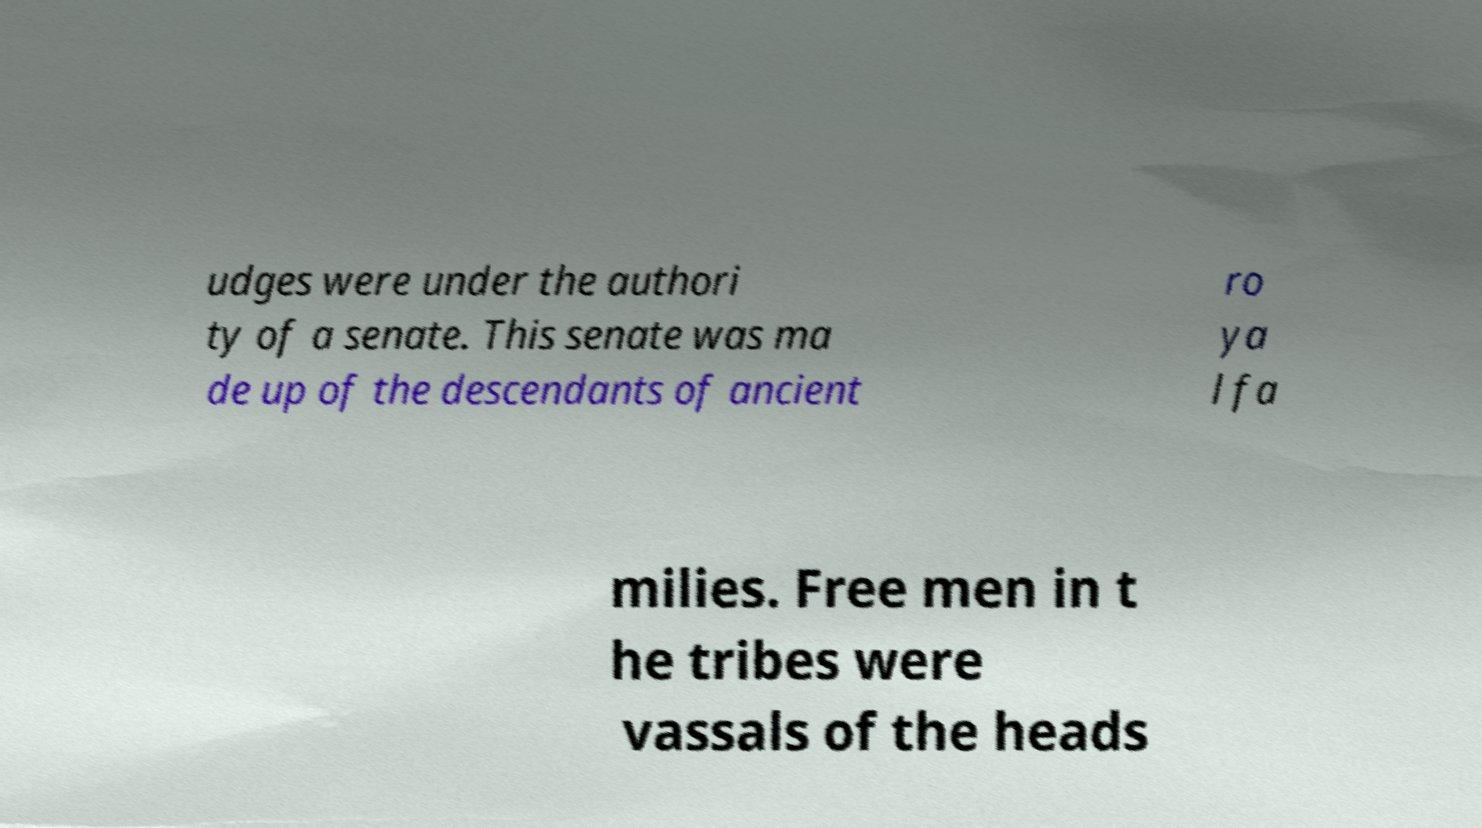Could you extract and type out the text from this image? udges were under the authori ty of a senate. This senate was ma de up of the descendants of ancient ro ya l fa milies. Free men in t he tribes were vassals of the heads 